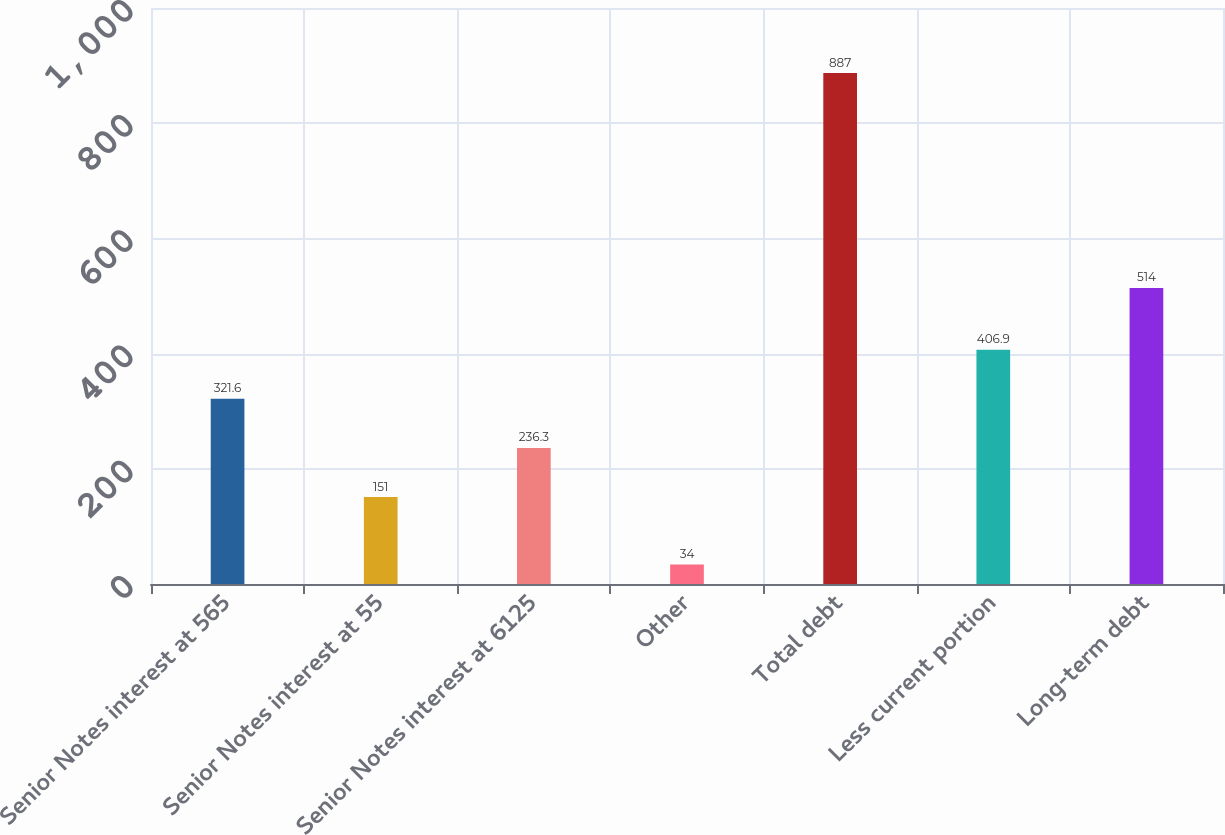<chart> <loc_0><loc_0><loc_500><loc_500><bar_chart><fcel>Senior Notes interest at 565<fcel>Senior Notes interest at 55<fcel>Senior Notes interest at 6125<fcel>Other<fcel>Total debt<fcel>Less current portion<fcel>Long-term debt<nl><fcel>321.6<fcel>151<fcel>236.3<fcel>34<fcel>887<fcel>406.9<fcel>514<nl></chart> 